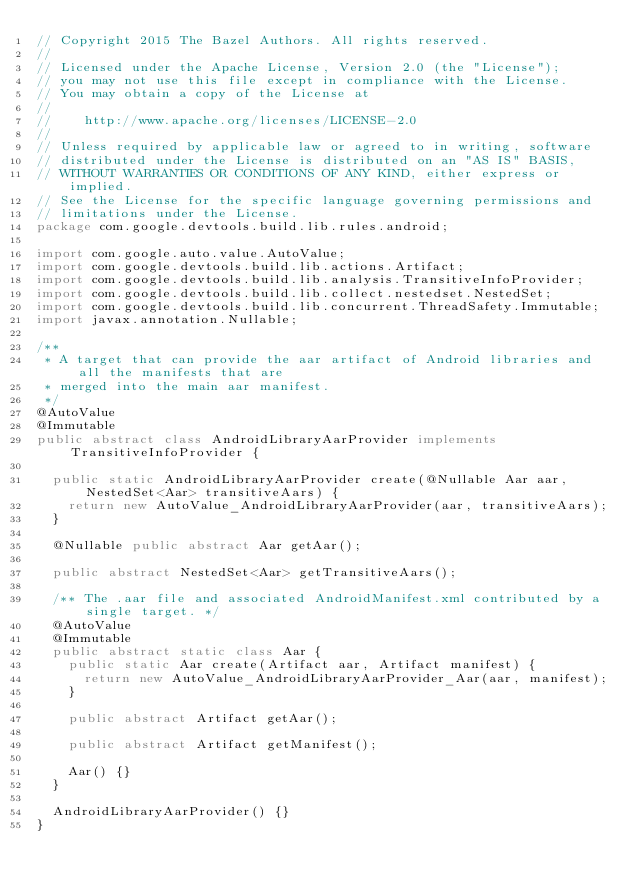Convert code to text. <code><loc_0><loc_0><loc_500><loc_500><_Java_>// Copyright 2015 The Bazel Authors. All rights reserved.
//
// Licensed under the Apache License, Version 2.0 (the "License");
// you may not use this file except in compliance with the License.
// You may obtain a copy of the License at
//
//    http://www.apache.org/licenses/LICENSE-2.0
//
// Unless required by applicable law or agreed to in writing, software
// distributed under the License is distributed on an "AS IS" BASIS,
// WITHOUT WARRANTIES OR CONDITIONS OF ANY KIND, either express or implied.
// See the License for the specific language governing permissions and
// limitations under the License.
package com.google.devtools.build.lib.rules.android;

import com.google.auto.value.AutoValue;
import com.google.devtools.build.lib.actions.Artifact;
import com.google.devtools.build.lib.analysis.TransitiveInfoProvider;
import com.google.devtools.build.lib.collect.nestedset.NestedSet;
import com.google.devtools.build.lib.concurrent.ThreadSafety.Immutable;
import javax.annotation.Nullable;

/**
 * A target that can provide the aar artifact of Android libraries and all the manifests that are
 * merged into the main aar manifest.
 */
@AutoValue
@Immutable
public abstract class AndroidLibraryAarProvider implements TransitiveInfoProvider {

  public static AndroidLibraryAarProvider create(@Nullable Aar aar, NestedSet<Aar> transitiveAars) {
    return new AutoValue_AndroidLibraryAarProvider(aar, transitiveAars);
  }

  @Nullable public abstract Aar getAar();

  public abstract NestedSet<Aar> getTransitiveAars();

  /** The .aar file and associated AndroidManifest.xml contributed by a single target. */
  @AutoValue
  @Immutable
  public abstract static class Aar {
    public static Aar create(Artifact aar, Artifact manifest) {
      return new AutoValue_AndroidLibraryAarProvider_Aar(aar, manifest);
    }

    public abstract Artifact getAar();

    public abstract Artifact getManifest();

    Aar() {}
  }

  AndroidLibraryAarProvider() {}
}
</code> 